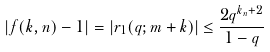Convert formula to latex. <formula><loc_0><loc_0><loc_500><loc_500>| f ( k , n ) - 1 | = \left | r _ { 1 } ( q ; m + k ) \right | \leq \frac { 2 q ^ { k _ { n } + 2 } } { 1 - q }</formula> 